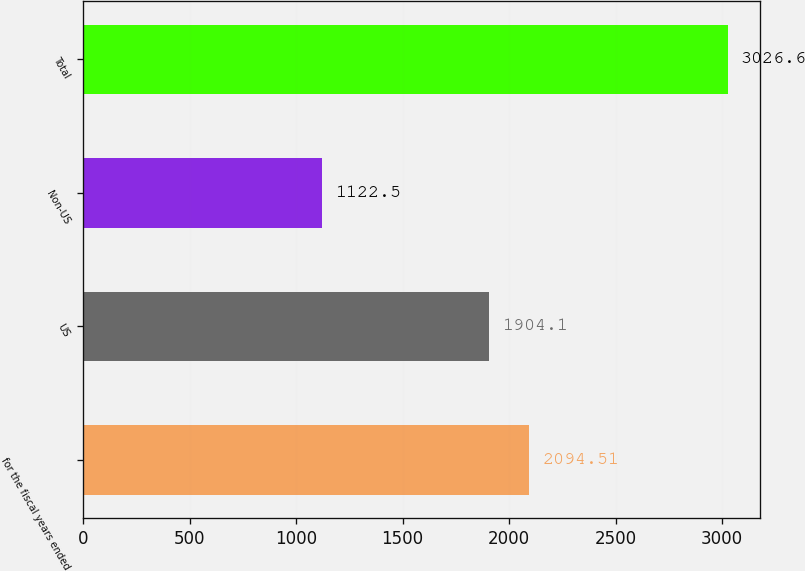Convert chart. <chart><loc_0><loc_0><loc_500><loc_500><bar_chart><fcel>for the fiscal years ended<fcel>US<fcel>Non-US<fcel>Total<nl><fcel>2094.51<fcel>1904.1<fcel>1122.5<fcel>3026.6<nl></chart> 